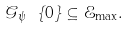<formula> <loc_0><loc_0><loc_500><loc_500>\mathcal { G } _ { \psi } \ \{ 0 \} \subseteq \mathcal { E } _ { \max } .</formula> 